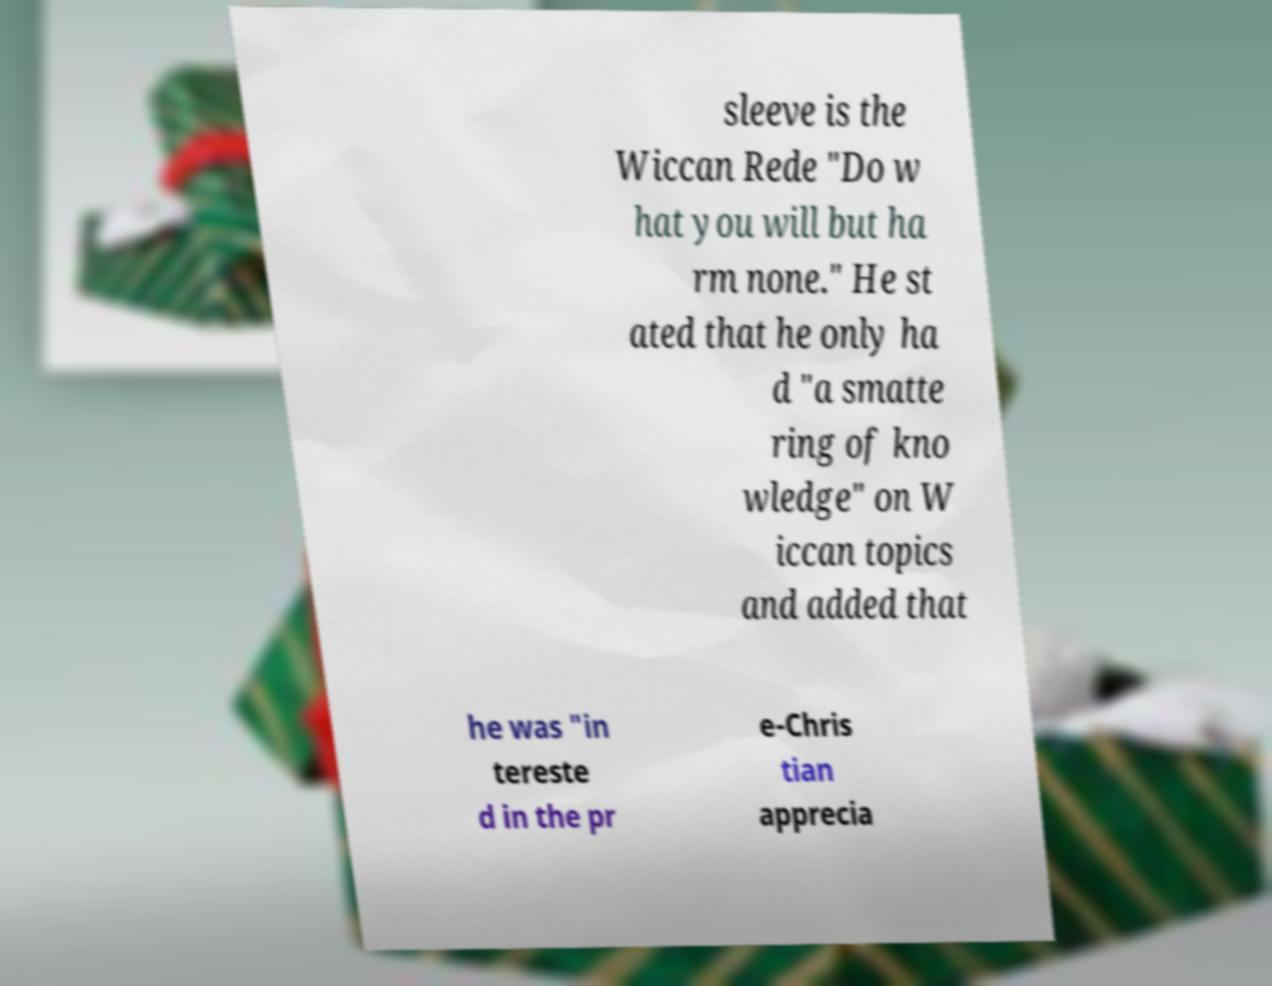Can you read and provide the text displayed in the image?This photo seems to have some interesting text. Can you extract and type it out for me? sleeve is the Wiccan Rede "Do w hat you will but ha rm none." He st ated that he only ha d "a smatte ring of kno wledge" on W iccan topics and added that he was "in tereste d in the pr e-Chris tian apprecia 